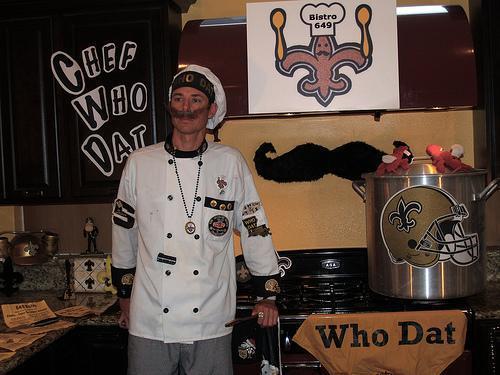How many people are in the photo?
Give a very brief answer. 1. 